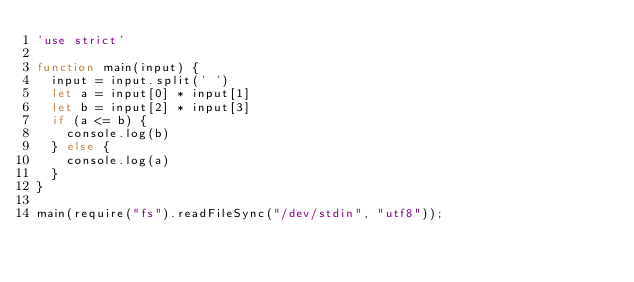<code> <loc_0><loc_0><loc_500><loc_500><_JavaScript_>'use strict'

function main(input) {
  input = input.split(' ')
  let a = input[0] * input[1]
  let b = input[2] * input[3]
  if (a <= b) {
    console.log(b)
  } else {
    console.log(a)
  }
}

main(require("fs").readFileSync("/dev/stdin", "utf8"));</code> 